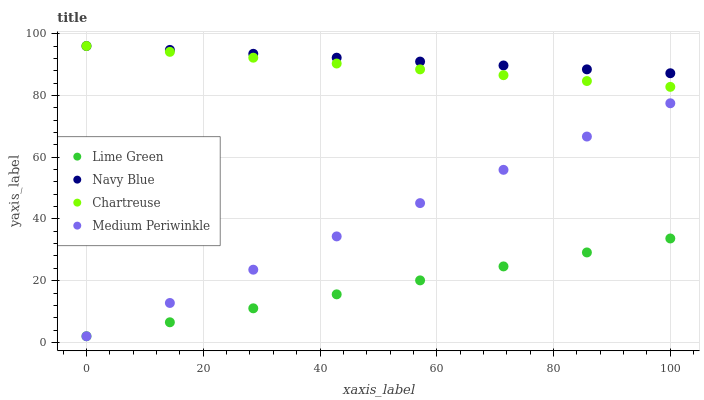Does Lime Green have the minimum area under the curve?
Answer yes or no. Yes. Does Navy Blue have the maximum area under the curve?
Answer yes or no. Yes. Does Chartreuse have the minimum area under the curve?
Answer yes or no. No. Does Chartreuse have the maximum area under the curve?
Answer yes or no. No. Is Lime Green the smoothest?
Answer yes or no. Yes. Is Chartreuse the roughest?
Answer yes or no. Yes. Is Chartreuse the smoothest?
Answer yes or no. No. Is Lime Green the roughest?
Answer yes or no. No. Does Lime Green have the lowest value?
Answer yes or no. Yes. Does Chartreuse have the lowest value?
Answer yes or no. No. Does Chartreuse have the highest value?
Answer yes or no. Yes. Does Lime Green have the highest value?
Answer yes or no. No. Is Lime Green less than Chartreuse?
Answer yes or no. Yes. Is Chartreuse greater than Lime Green?
Answer yes or no. Yes. Does Medium Periwinkle intersect Lime Green?
Answer yes or no. Yes. Is Medium Periwinkle less than Lime Green?
Answer yes or no. No. Is Medium Periwinkle greater than Lime Green?
Answer yes or no. No. Does Lime Green intersect Chartreuse?
Answer yes or no. No. 